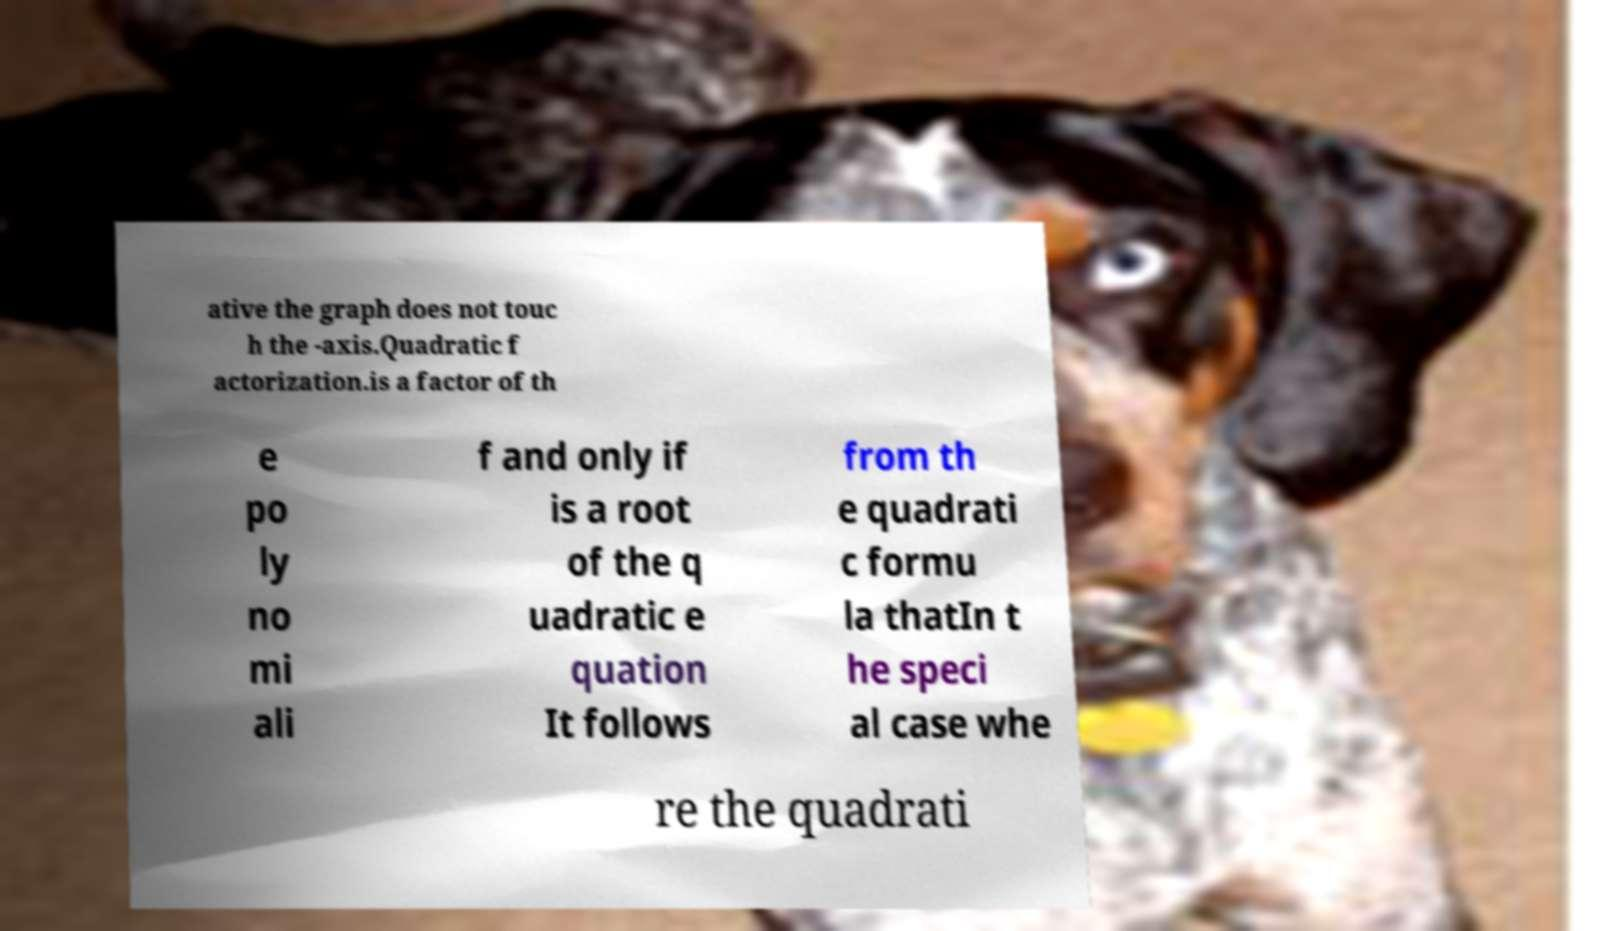What messages or text are displayed in this image? I need them in a readable, typed format. ative the graph does not touc h the -axis.Quadratic f actorization.is a factor of th e po ly no mi ali f and only if is a root of the q uadratic e quation It follows from th e quadrati c formu la thatIn t he speci al case whe re the quadrati 